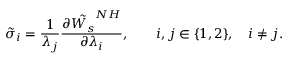<formula> <loc_0><loc_0><loc_500><loc_500>\tilde { \sigma } _ { i } = \frac { 1 } { \lambda _ { j } } \frac { \partial \tilde { W _ { s } } ^ { N H } } { \partial \lambda _ { i } } , \quad i , j \in \{ 1 , 2 \} , \quad i \neq j .</formula> 